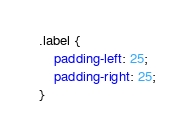Convert code to text. <code><loc_0><loc_0><loc_500><loc_500><_CSS_>.label {
    padding-left: 25;
    padding-right: 25;
}</code> 